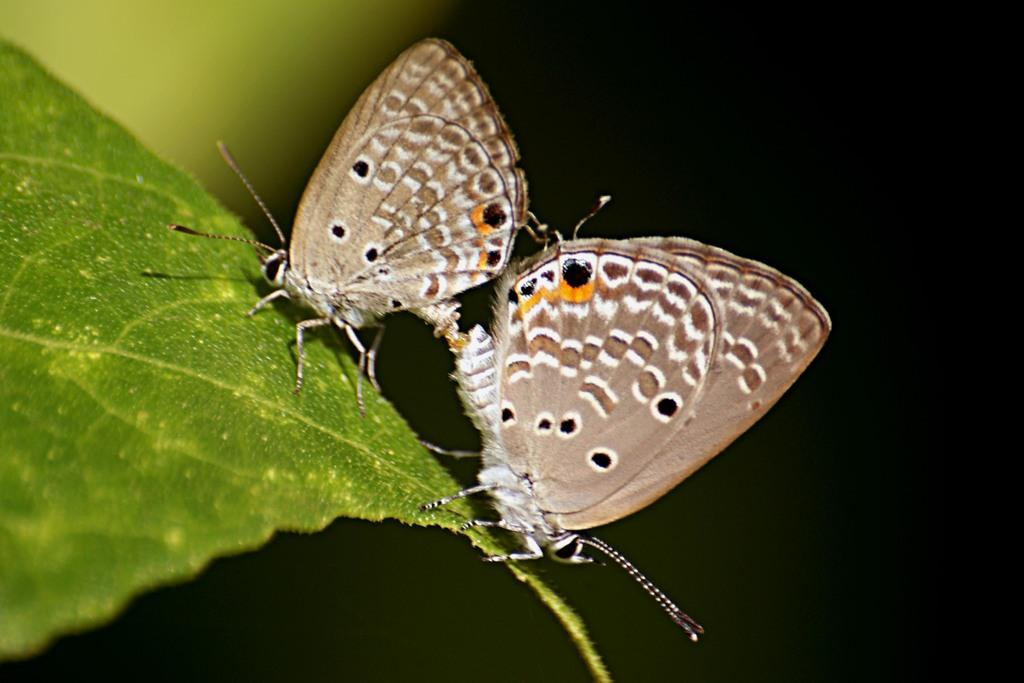How many butterflies are present in the image? There are 2 butterflies in the image. What colors can be seen on the butterflies? The butterflies have white, brown, orange, and black colors. Where are the butterflies located in the image? The butterflies are on a green leaf. What is the color of the background in the image? The background of the image is dark. What type of bread can be seen in the image? There is no bread present in the image; it features 2 butterflies on a green leaf with a dark background. Can you tell me how many pieces of coal are visible in the image? There is no coal present in the image; it features 2 butterflies on a green leaf with a dark background. 